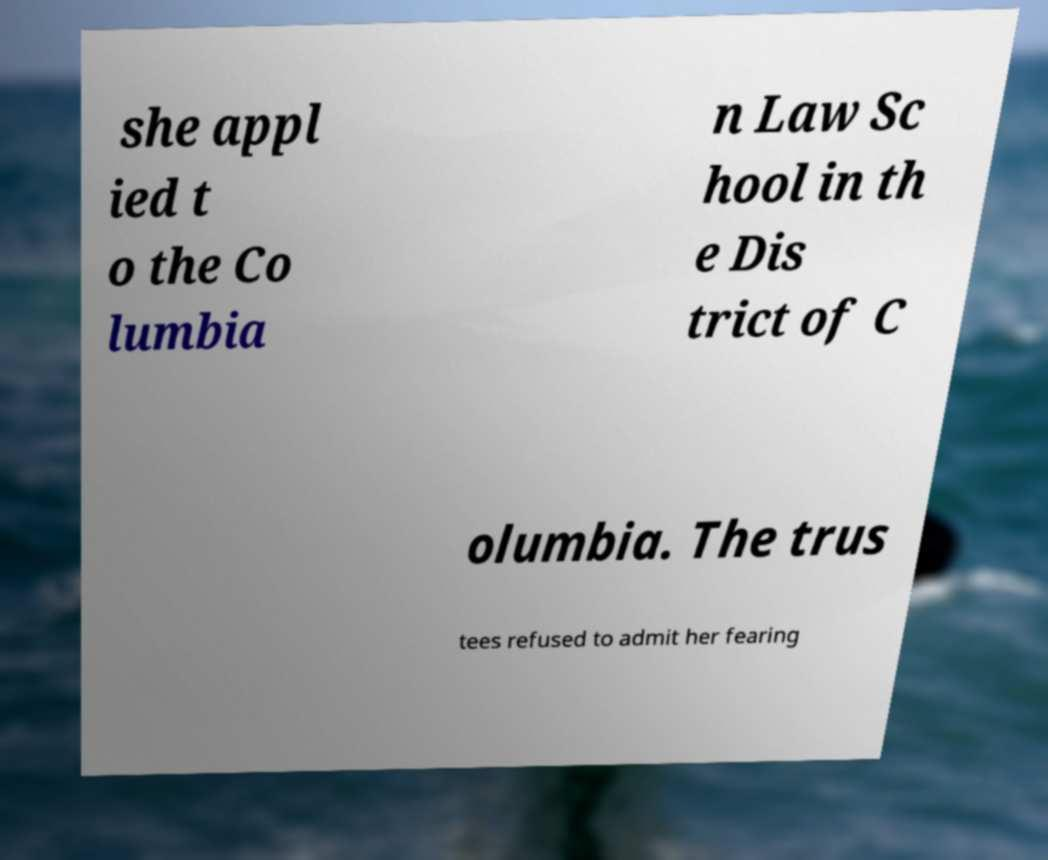Could you assist in decoding the text presented in this image and type it out clearly? she appl ied t o the Co lumbia n Law Sc hool in th e Dis trict of C olumbia. The trus tees refused to admit her fearing 